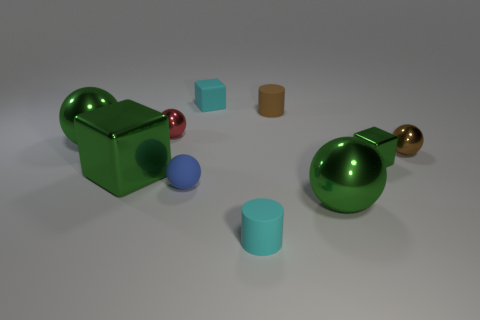Subtract all metallic balls. How many balls are left? 1 Subtract all blue spheres. How many spheres are left? 4 Subtract 1 balls. How many balls are left? 4 Subtract all purple balls. Subtract all purple cubes. How many balls are left? 5 Subtract all blocks. How many objects are left? 7 Add 9 big yellow rubber blocks. How many big yellow rubber blocks exist? 9 Subtract 0 cyan balls. How many objects are left? 10 Subtract all small brown rubber cylinders. Subtract all large metallic things. How many objects are left? 6 Add 8 large green metallic cubes. How many large green metallic cubes are left? 9 